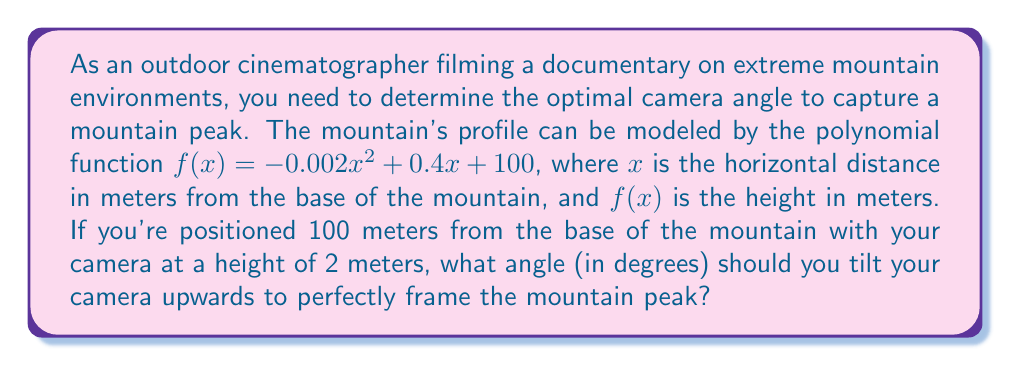Solve this math problem. Let's approach this step-by-step:

1) First, we need to find the location of the mountain peak. This occurs at the vertex of the parabola described by $f(x)$. For a quadratic function $ax^2 + bx + c$, the x-coordinate of the vertex is given by $x = -b/(2a)$.

   $a = -0.002$, $b = 0.4$
   $x = -0.4 / (2 * (-0.002)) = 100$ meters

2) Now we know the peak is located at $x = 100$ meters from the base. Let's find its height:

   $f(100) = -0.002(100)^2 + 0.4(100) + 100 = 120$ meters

3) We now have two points:
   - The camera position: (100, 2)
   - The mountain peak: (100, 120)

4) To find the angle, we need to calculate the arctangent of the slope between these points:

   Slope = (120 - 2) / (100 - 100) = 118 / 0

   However, we can't divide by zero. This means our camera is directly below the peak, so we need to find the angle between a vertical line and our camera line of sight.

5) The angle can be calculated using:

   $\theta = \arctan(\frac{\text{opposite}}{\text{adjacent}}) = \arctan(\frac{118}{0})$

   This equals 90° (straight up), but we need to subtract the small angle due to our camera height:

   $\theta = 90° - \arctan(\frac{2}{100}) = 90° - \arctan(0.02)$

6) Calculate the final angle:

   $\theta = 90° - 1.1458° = 88.8542°$
Answer: 88.85° 